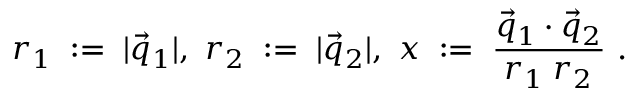Convert formula to latex. <formula><loc_0><loc_0><loc_500><loc_500>r _ { 1 } \, \colon = \, | \vec { q } _ { 1 } | , \ r _ { 2 } \, \colon = \, | \vec { q } _ { 2 } | , \ x \, \colon = \, \frac { \vec { q } _ { 1 } \cdot \vec { q } _ { 2 } } { r _ { 1 } \, r _ { 2 } } \ .</formula> 